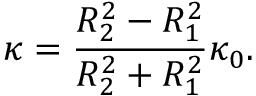<formula> <loc_0><loc_0><loc_500><loc_500>\kappa = \frac { R _ { 2 } ^ { 2 } - R _ { 1 } ^ { 2 } } { R _ { 2 } ^ { 2 } + R _ { 1 } ^ { 2 } } \kappa _ { 0 } .</formula> 